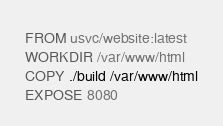Convert code to text. <code><loc_0><loc_0><loc_500><loc_500><_Dockerfile_>FROM usvc/website:latest
WORKDIR /var/www/html
COPY ./build /var/www/html
EXPOSE 8080
</code> 